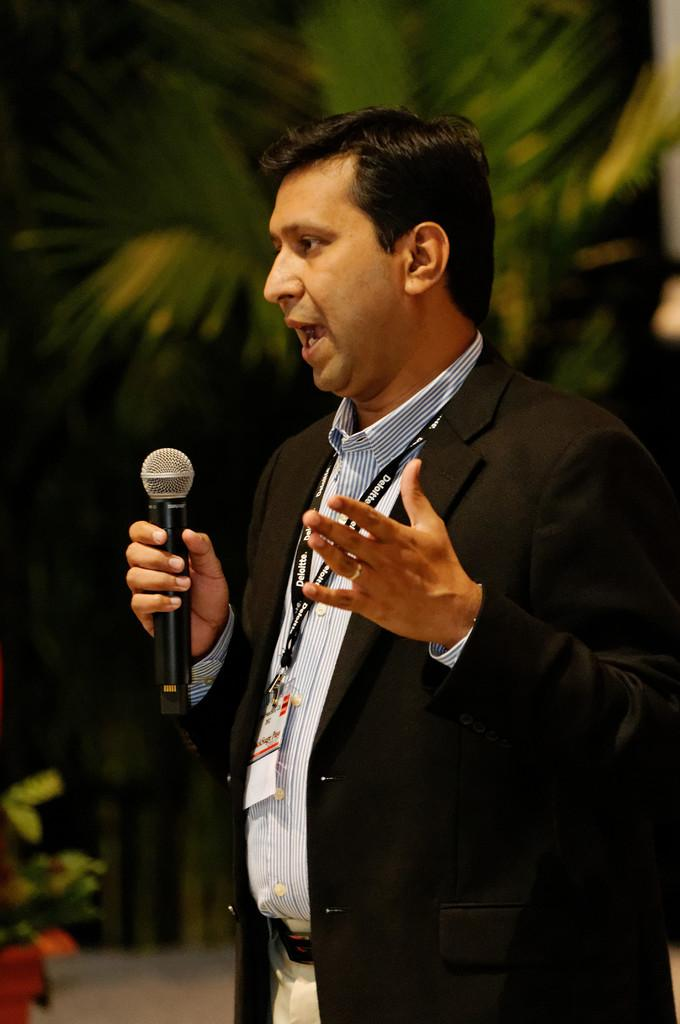What is the man in the image doing? The man is standing and talking in the image. What is the man holding in the image? The man is holding a microphone in the image. What can be seen in the background of the image? There is a tree visible in the background of the image. What type of crime is being committed in the image? There is no indication of any crime being committed in the image. The man is simply standing and talking while holding a microphone. 